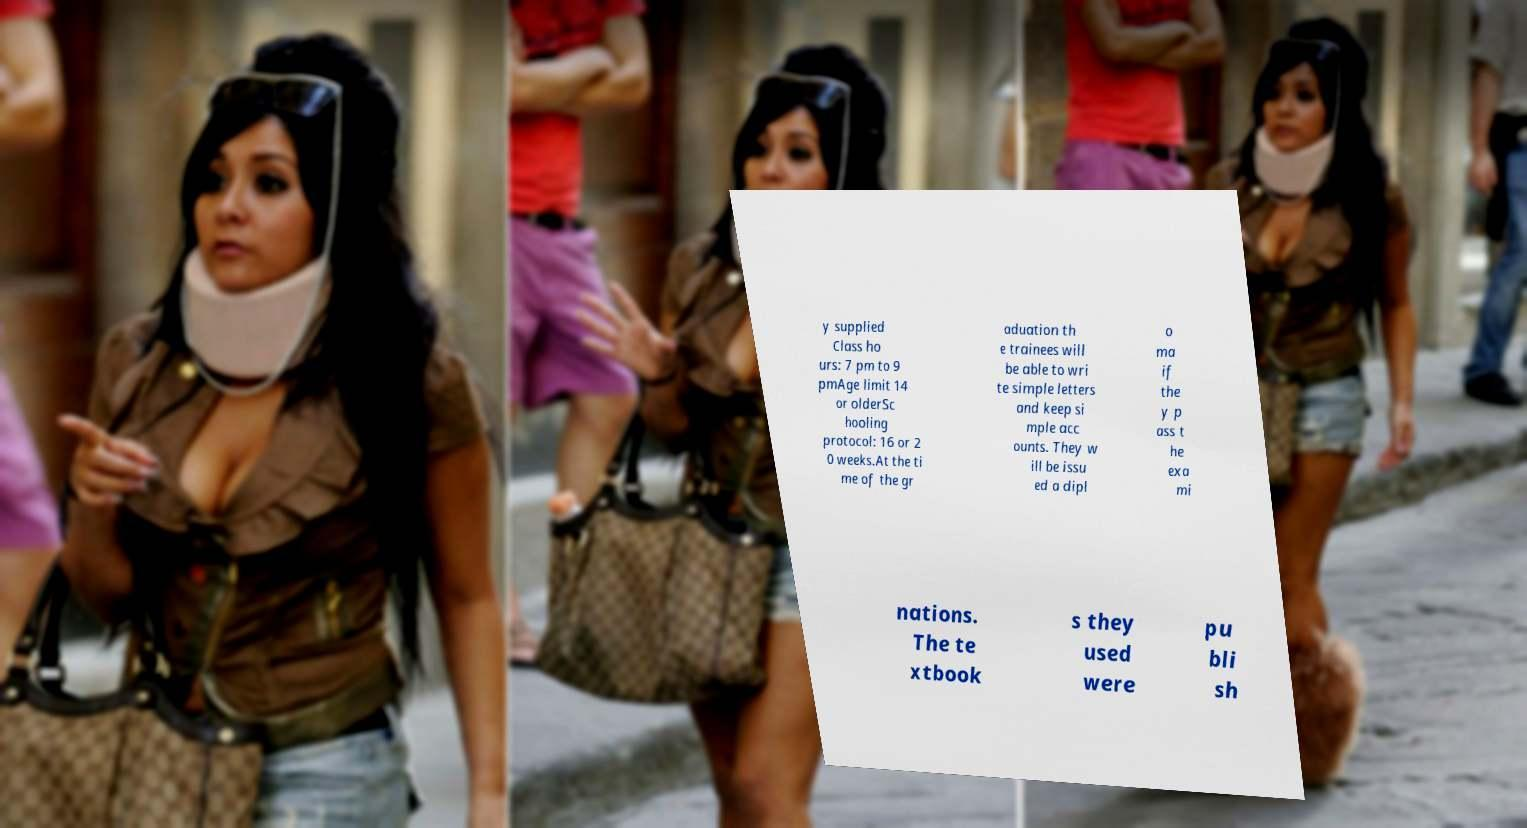Please read and relay the text visible in this image. What does it say? y supplied Class ho urs: 7 pm to 9 pmAge limit 14 or olderSc hooling protocol: 16 or 2 0 weeks.At the ti me of the gr aduation th e trainees will be able to wri te simple letters and keep si mple acc ounts. They w ill be issu ed a dipl o ma if the y p ass t he exa mi nations. The te xtbook s they used were pu bli sh 